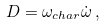Convert formula to latex. <formula><loc_0><loc_0><loc_500><loc_500>D = \omega _ { c h a r } \dot { \omega } \, ,</formula> 